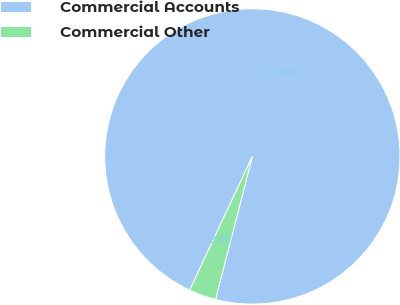<chart> <loc_0><loc_0><loc_500><loc_500><pie_chart><fcel>Commercial Accounts<fcel>Commercial Other<nl><fcel>97.04%<fcel>2.96%<nl></chart> 